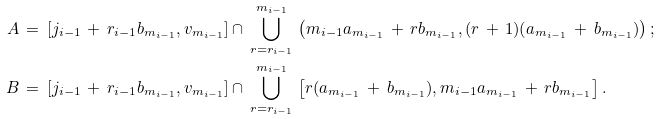<formula> <loc_0><loc_0><loc_500><loc_500>A & \, = \, [ j _ { i - 1 } \, + \, r _ { i - 1 } b _ { m _ { i - 1 } } , v _ { m _ { i - 1 } } ] \cap \, \bigcup _ { r = r _ { i - 1 } } ^ { m _ { i - 1 } } \, \left ( m _ { i - 1 } a _ { m _ { i - 1 } } \, + \, r b _ { m _ { i - 1 } } , ( r \, + \, 1 ) ( a _ { m _ { i - 1 } } \, + \, b _ { m _ { i - 1 } } ) \right ) ; \\ B & \, = \, [ j _ { i - 1 } \, + \, r _ { i - 1 } b _ { m _ { i - 1 } } , v _ { m _ { i - 1 } } ] \cap \, \bigcup _ { r = r _ { i - 1 } } ^ { m _ { i - 1 } } \, \left [ r ( a _ { m _ { i - 1 } } \, + \, b _ { m _ { i - 1 } } ) , m _ { i - 1 } a _ { m _ { i - 1 } } \, + \, r b _ { m _ { i - 1 } } \right ] .</formula> 